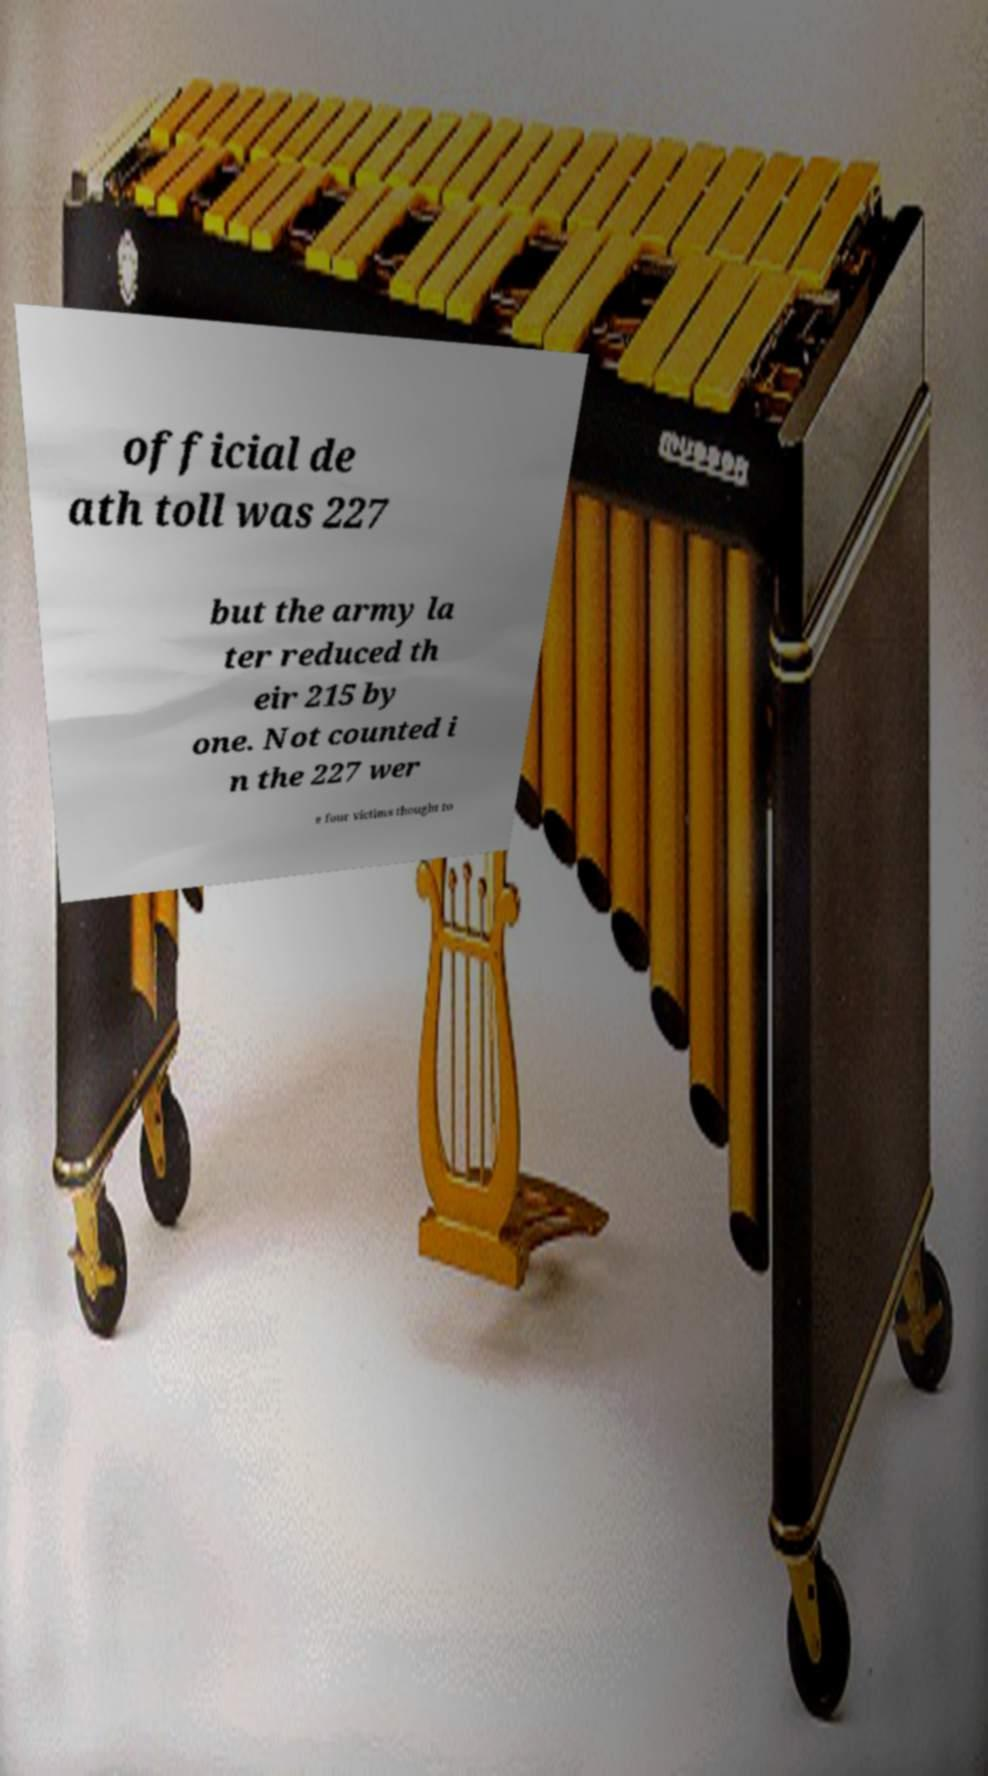Can you read and provide the text displayed in the image?This photo seems to have some interesting text. Can you extract and type it out for me? official de ath toll was 227 but the army la ter reduced th eir 215 by one. Not counted i n the 227 wer e four victims thought to 